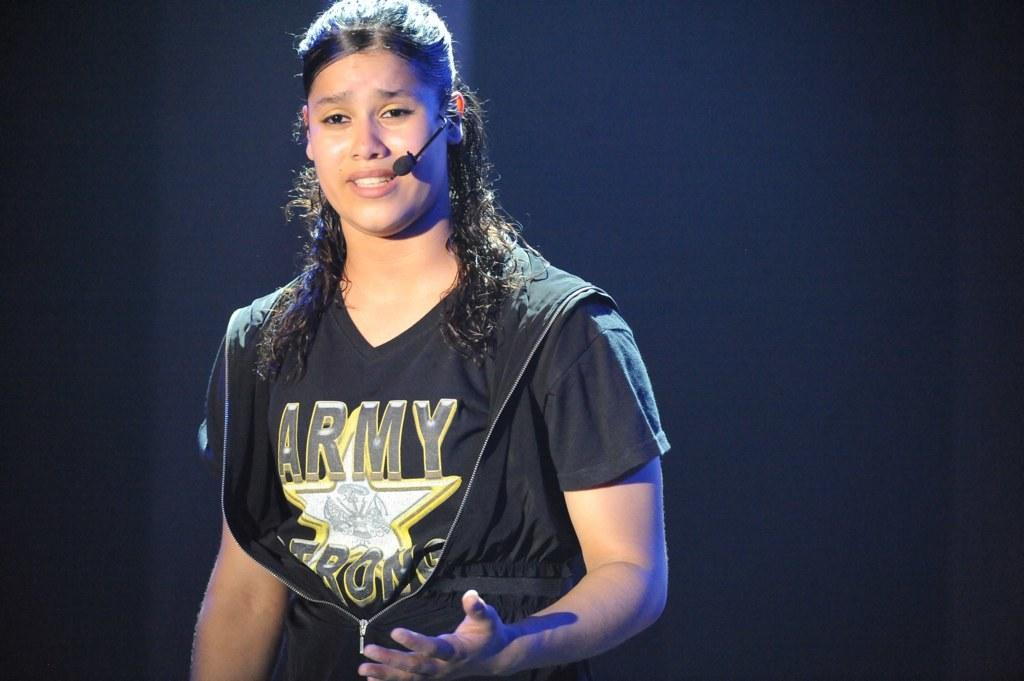<image>
Summarize the visual content of the image. a lady is wearing a shirt that says army on it 